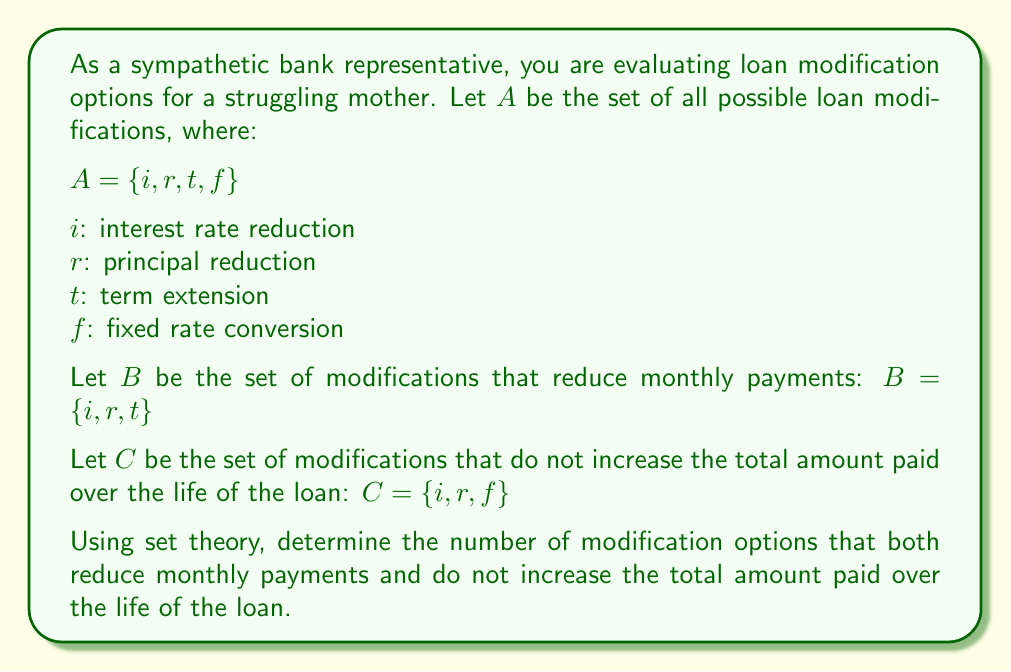Can you solve this math problem? To solve this problem, we need to find the intersection of sets $B$ and $C$. This intersection will represent the loan modification options that satisfy both conditions: reducing monthly payments and not increasing the total amount paid over the life of the loan.

Step 1: Identify the elements in each set
$B = \{i, r, t\}$
$C = \{i, r, f\}$

Step 2: Find the intersection of sets $B$ and $C$
The intersection of two sets is denoted as $B \cap C$ and contains all elements that are in both sets.

$B \cap C = \{i, r\}$

We can see that $i$ (interest rate reduction) and $r$ (principal reduction) are present in both sets.

Step 3: Count the number of elements in the intersection
The number of elements in $B \cap C$ is 2.

Therefore, there are 2 modification options that both reduce monthly payments and do not increase the total amount paid over the life of the loan.
Answer: 2 